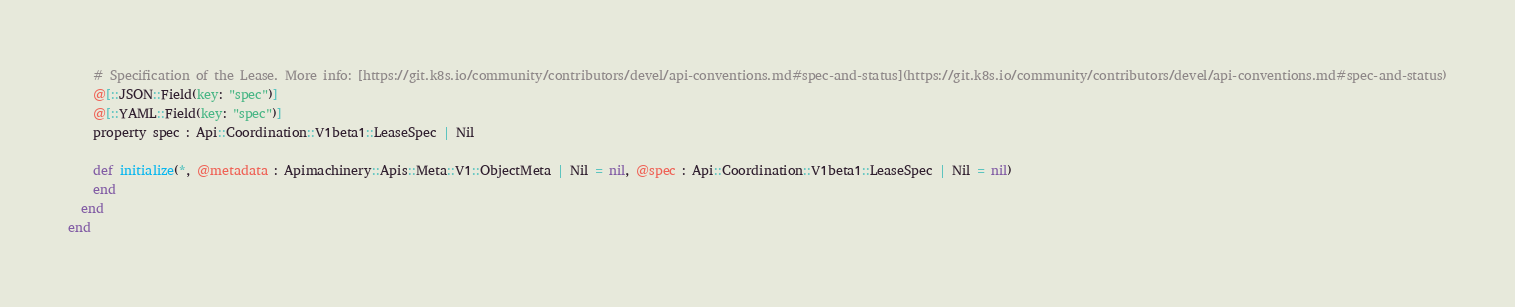Convert code to text. <code><loc_0><loc_0><loc_500><loc_500><_Crystal_>    # Specification of the Lease. More info: [https://git.k8s.io/community/contributors/devel/api-conventions.md#spec-and-status](https://git.k8s.io/community/contributors/devel/api-conventions.md#spec-and-status)
    @[::JSON::Field(key: "spec")]
    @[::YAML::Field(key: "spec")]
    property spec : Api::Coordination::V1beta1::LeaseSpec | Nil

    def initialize(*, @metadata : Apimachinery::Apis::Meta::V1::ObjectMeta | Nil = nil, @spec : Api::Coordination::V1beta1::LeaseSpec | Nil = nil)
    end
  end
end
</code> 